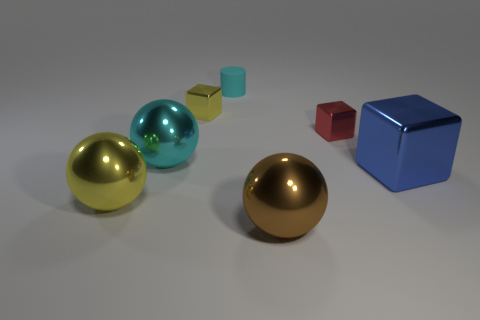Subtract all large cyan spheres. How many spheres are left? 2 Add 1 small shiny cubes. How many objects exist? 8 Subtract all cubes. How many objects are left? 4 Subtract 1 brown spheres. How many objects are left? 6 Subtract all big cubes. Subtract all blue blocks. How many objects are left? 5 Add 1 cyan cylinders. How many cyan cylinders are left? 2 Add 7 large yellow cylinders. How many large yellow cylinders exist? 7 